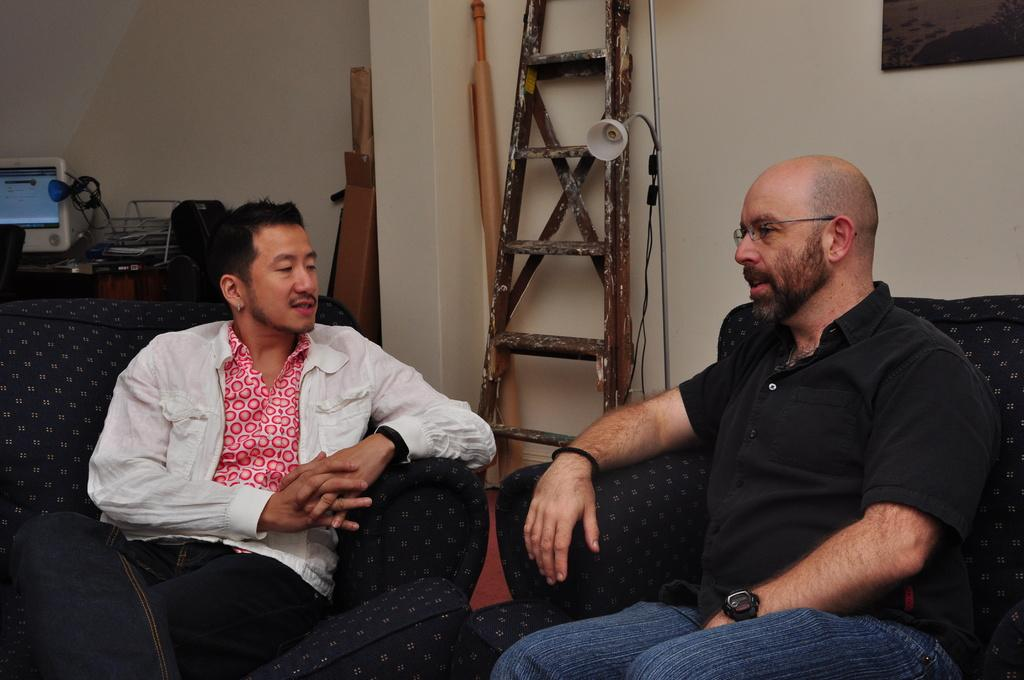How many people are the people are positioned in the image? There are two people sitting on a couch in the image. What is the main piece of furniture in the image? There is a table in the image. What is placed on the table? A monitor is present on the table, along with a cable and other things. What is the purpose of the ladder in the image? There is a ladder in the image, but its purpose is not clear from the facts provided. What is the source of light near the ladder? A lamp is beside the ladder in the image. What is hanging on the wall in the image? There is a picture on the wall in the image. What activity are the people feeling while sitting on the couch? There is no information about the people's feelings or any activity they might be feeling in the image. 